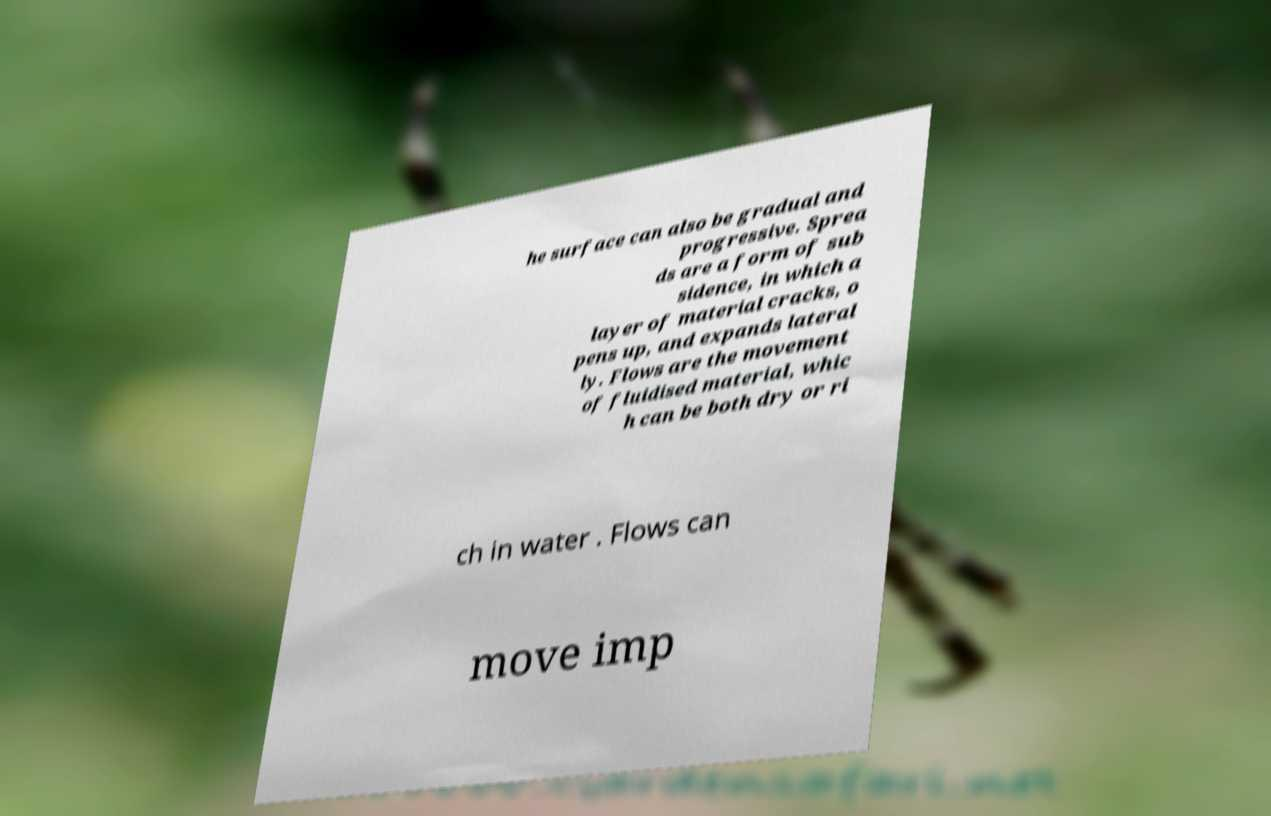There's text embedded in this image that I need extracted. Can you transcribe it verbatim? he surface can also be gradual and progressive. Sprea ds are a form of sub sidence, in which a layer of material cracks, o pens up, and expands lateral ly. Flows are the movement of fluidised material, whic h can be both dry or ri ch in water . Flows can move imp 